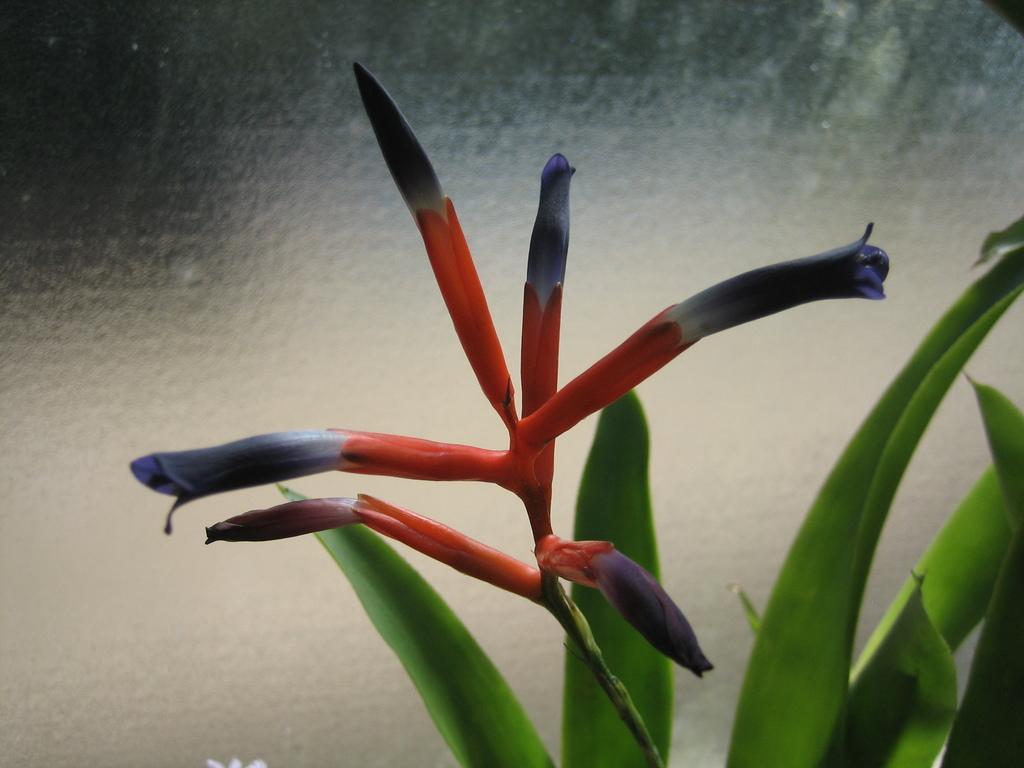Describe this image in one or two sentences. In this image we can see some flowers and buds to the stem of a plant. We can also see some leaves. 